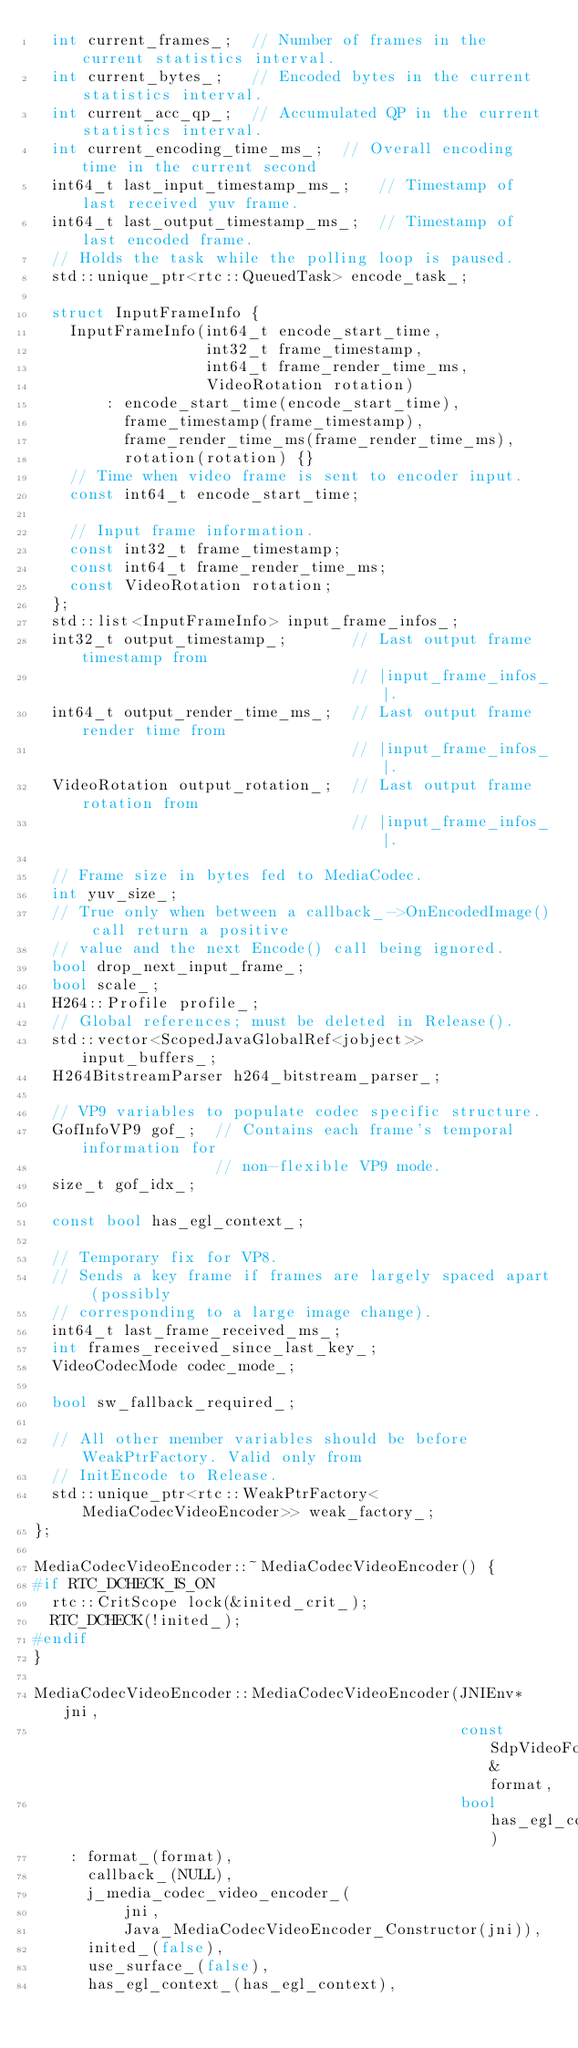<code> <loc_0><loc_0><loc_500><loc_500><_C++_>  int current_frames_;  // Number of frames in the current statistics interval.
  int current_bytes_;   // Encoded bytes in the current statistics interval.
  int current_acc_qp_;  // Accumulated QP in the current statistics interval.
  int current_encoding_time_ms_;  // Overall encoding time in the current second
  int64_t last_input_timestamp_ms_;   // Timestamp of last received yuv frame.
  int64_t last_output_timestamp_ms_;  // Timestamp of last encoded frame.
  // Holds the task while the polling loop is paused.
  std::unique_ptr<rtc::QueuedTask> encode_task_;

  struct InputFrameInfo {
    InputFrameInfo(int64_t encode_start_time,
                   int32_t frame_timestamp,
                   int64_t frame_render_time_ms,
                   VideoRotation rotation)
        : encode_start_time(encode_start_time),
          frame_timestamp(frame_timestamp),
          frame_render_time_ms(frame_render_time_ms),
          rotation(rotation) {}
    // Time when video frame is sent to encoder input.
    const int64_t encode_start_time;

    // Input frame information.
    const int32_t frame_timestamp;
    const int64_t frame_render_time_ms;
    const VideoRotation rotation;
  };
  std::list<InputFrameInfo> input_frame_infos_;
  int32_t output_timestamp_;       // Last output frame timestamp from
                                   // |input_frame_infos_|.
  int64_t output_render_time_ms_;  // Last output frame render time from
                                   // |input_frame_infos_|.
  VideoRotation output_rotation_;  // Last output frame rotation from
                                   // |input_frame_infos_|.

  // Frame size in bytes fed to MediaCodec.
  int yuv_size_;
  // True only when between a callback_->OnEncodedImage() call return a positive
  // value and the next Encode() call being ignored.
  bool drop_next_input_frame_;
  bool scale_;
  H264::Profile profile_;
  // Global references; must be deleted in Release().
  std::vector<ScopedJavaGlobalRef<jobject>> input_buffers_;
  H264BitstreamParser h264_bitstream_parser_;

  // VP9 variables to populate codec specific structure.
  GofInfoVP9 gof_;  // Contains each frame's temporal information for
                    // non-flexible VP9 mode.
  size_t gof_idx_;

  const bool has_egl_context_;

  // Temporary fix for VP8.
  // Sends a key frame if frames are largely spaced apart (possibly
  // corresponding to a large image change).
  int64_t last_frame_received_ms_;
  int frames_received_since_last_key_;
  VideoCodecMode codec_mode_;

  bool sw_fallback_required_;

  // All other member variables should be before WeakPtrFactory. Valid only from
  // InitEncode to Release.
  std::unique_ptr<rtc::WeakPtrFactory<MediaCodecVideoEncoder>> weak_factory_;
};

MediaCodecVideoEncoder::~MediaCodecVideoEncoder() {
#if RTC_DCHECK_IS_ON
  rtc::CritScope lock(&inited_crit_);
  RTC_DCHECK(!inited_);
#endif
}

MediaCodecVideoEncoder::MediaCodecVideoEncoder(JNIEnv* jni,
                                               const SdpVideoFormat& format,
                                               bool has_egl_context)
    : format_(format),
      callback_(NULL),
      j_media_codec_video_encoder_(
          jni,
          Java_MediaCodecVideoEncoder_Constructor(jni)),
      inited_(false),
      use_surface_(false),
      has_egl_context_(has_egl_context),</code> 